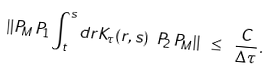<formula> <loc_0><loc_0><loc_500><loc_500>\| P _ { M } \, P _ { 1 } \int _ { t } ^ { s } d r K _ { \tau } ( r , s ) \ P _ { 2 } \, P _ { M } \| \ \leq \ \frac { C } { \Delta \tau } \, .</formula> 